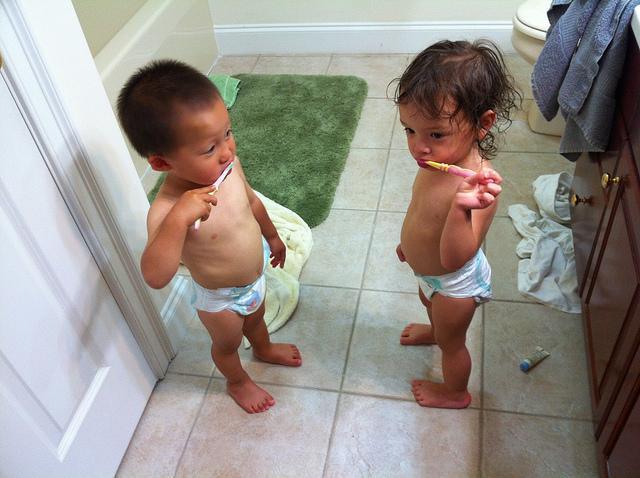How many of these people's feet are on the ground?
Give a very brief answer. 2. How many people are in the photo?
Give a very brief answer. 2. How many cats have their eyes closed?
Give a very brief answer. 0. 